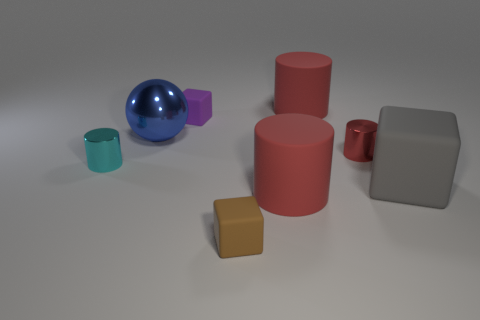There is a brown rubber object that is the same shape as the purple thing; what size is it?
Make the answer very short. Small. What color is the big matte thing that is the same shape as the small purple thing?
Offer a terse response. Gray. There is a gray object that is the same size as the metal ball; what is it made of?
Keep it short and to the point. Rubber. What is the shape of the gray object that is the same size as the blue shiny object?
Ensure brevity in your answer.  Cube. What is the large blue ball made of?
Your answer should be very brief. Metal. What color is the big matte object that is in front of the tiny purple rubber cube and to the left of the tiny red shiny cylinder?
Provide a short and direct response. Red. Is the number of rubber things in front of the big shiny sphere the same as the number of large gray rubber cubes left of the purple cube?
Offer a very short reply. No. What is the color of the other large cube that is made of the same material as the purple block?
Offer a very short reply. Gray. Is the color of the large ball the same as the small object that is on the left side of the blue metallic ball?
Give a very brief answer. No. There is a big red thing behind the big gray cube that is to the right of the tiny brown rubber thing; are there any big gray matte things in front of it?
Offer a very short reply. Yes. 